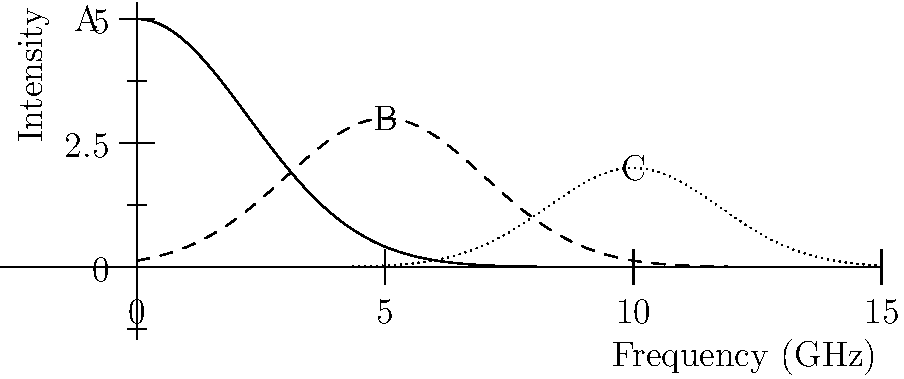The graph shows the frequency spectrum of three different radio wave sources observed during a celestial survey. Which curve represents the radio waves with the highest frequency? To determine which curve represents the radio waves with the highest frequency, we need to follow these steps:

1. Understand the x-axis: The x-axis represents frequency in GHz (gigahertz).
2. Identify the curves: There are three curves labeled A, B, and C.
3. Analyze the peak positions:
   - Curve A peaks at approximately 0 GHz
   - Curve B peaks at approximately 5 GHz
   - Curve C peaks at approximately 10 GHz
4. Compare the peak positions: The curve with its peak furthest to the right on the x-axis represents the highest frequency.
5. Conclusion: Curve C has its peak at the highest frequency (around 10 GHz).

Therefore, curve C represents the radio waves with the highest frequency.
Answer: Curve C 